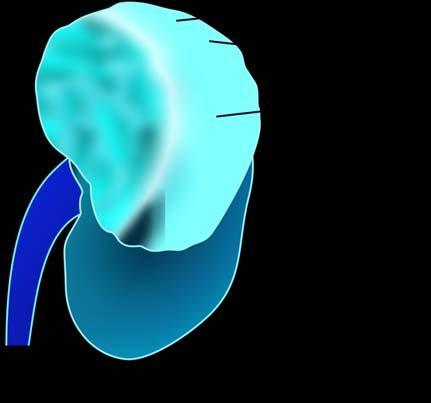does their lumina have reniform contour?
Answer the question using a single word or phrase. No 